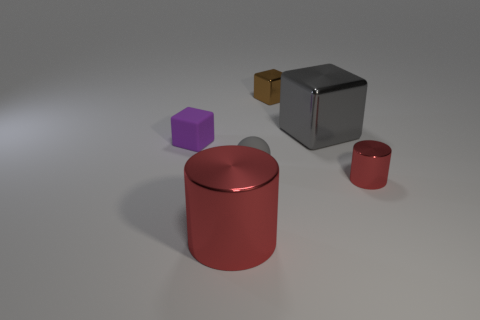Is there any other thing that has the same size as the purple cube?
Your answer should be compact. Yes. There is a big object behind the tiny red thing; is its shape the same as the rubber object that is on the right side of the tiny purple rubber object?
Keep it short and to the point. No. What shape is the gray thing that is the same size as the matte block?
Your answer should be compact. Sphere. Are there the same number of small brown cubes that are in front of the gray rubber thing and tiny blocks to the left of the tiny red metallic object?
Your response must be concise. No. Is there anything else that is the same shape as the gray matte object?
Offer a very short reply. No. Is the material of the red cylinder that is on the right side of the tiny gray ball the same as the large red object?
Your answer should be very brief. Yes. There is a red cylinder that is the same size as the ball; what is it made of?
Offer a terse response. Metal. How many other objects are the same material as the big red cylinder?
Keep it short and to the point. 3. There is a purple rubber thing; is it the same size as the red metallic cylinder on the right side of the small matte sphere?
Your response must be concise. Yes. Are there fewer small things that are to the right of the brown block than big gray cubes that are in front of the matte sphere?
Ensure brevity in your answer.  No. 